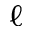<formula> <loc_0><loc_0><loc_500><loc_500>\ell</formula> 